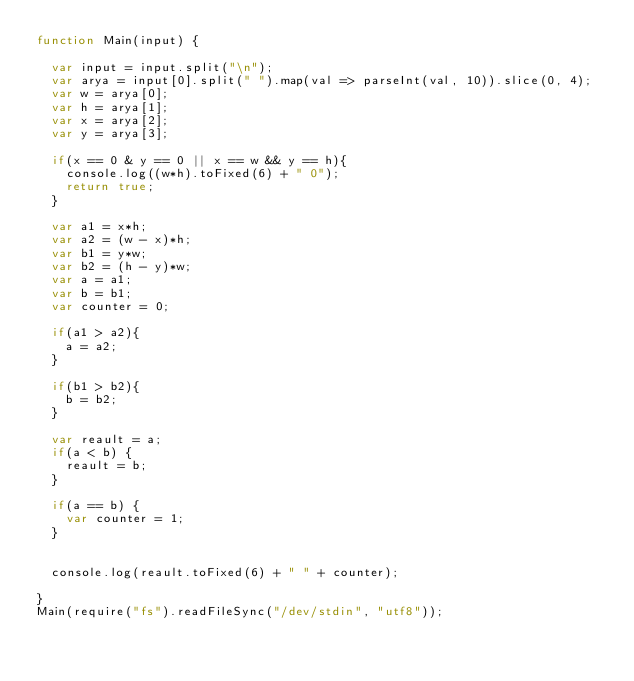Convert code to text. <code><loc_0><loc_0><loc_500><loc_500><_JavaScript_>function Main(input) {

  var input = input.split("\n");
  var arya = input[0].split(" ").map(val => parseInt(val, 10)).slice(0, 4);
  var w = arya[0];
  var h = arya[1];
  var x = arya[2];
  var y = arya[3];

  if(x == 0 & y == 0 || x == w && y == h){
    console.log((w*h).toFixed(6) + " 0");
    return true;
  }

  var a1 = x*h;
  var a2 = (w - x)*h;
  var b1 = y*w;
  var b2 = (h - y)*w;
  var a = a1;
  var b = b1;
  var counter = 0;

  if(a1 > a2){
    a = a2;
  }

  if(b1 > b2){
    b = b2;
  }

  var reault = a;
  if(a < b) {
    reault = b;
  }

  if(a == b) {
    var counter = 1;
  }


  console.log(reault.toFixed(6) + " " + counter);

}
Main(require("fs").readFileSync("/dev/stdin", "utf8"));</code> 